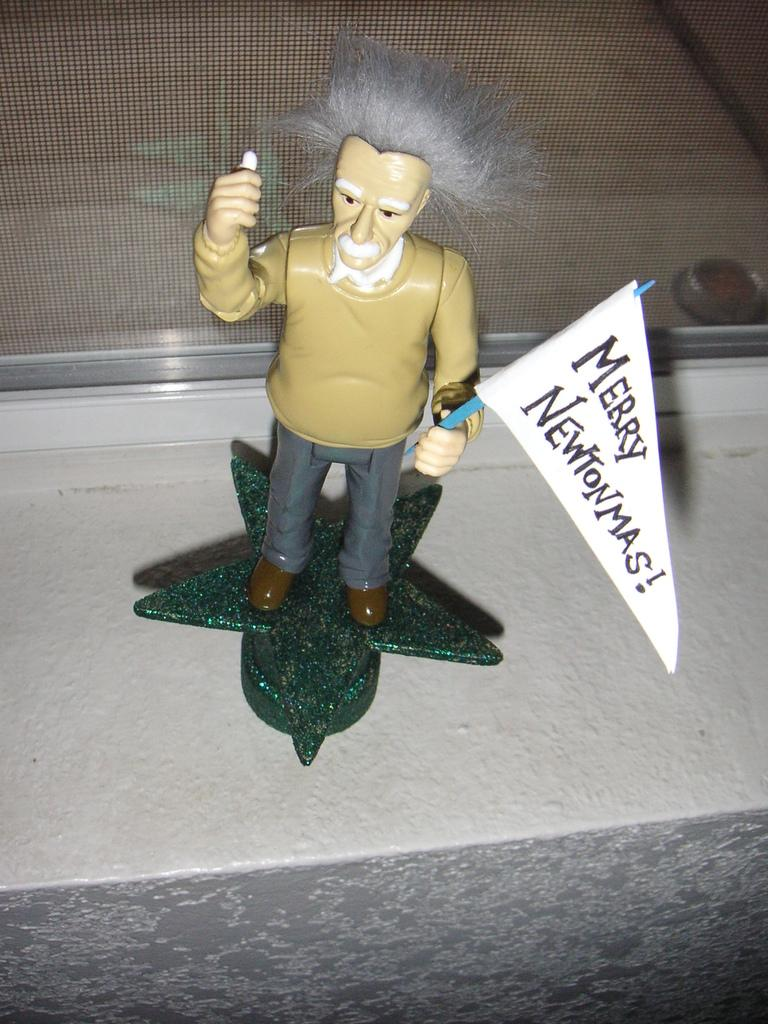What is the main subject of the image? There is a figurine in the image. What is the figurine placed on? The figurine is on a star-type decorative item. What is the figurine holding? The figurine is holding a flag. What can be seen on the flag? There is text on the flag. How many balloons are tied to the figurine in the image? There are no balloons present in the image. What company does the figurine represent in the image? The image does not provide information about any company affiliation with the figurine. 